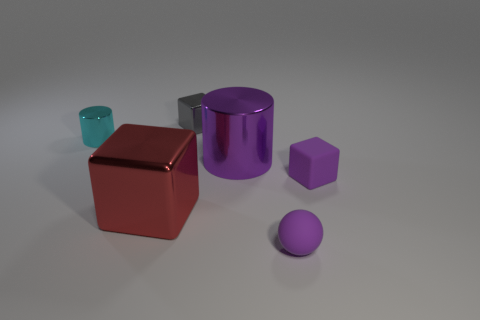Subtract all metal blocks. How many blocks are left? 1 Subtract 1 cubes. How many cubes are left? 2 Add 1 cyan matte cylinders. How many objects exist? 7 Subtract all cylinders. How many objects are left? 4 Subtract all cyan cylinders. How many cylinders are left? 1 Add 2 tiny cylinders. How many tiny cylinders exist? 3 Subtract 0 green cylinders. How many objects are left? 6 Subtract all brown spheres. Subtract all purple cubes. How many spheres are left? 1 Subtract all small purple matte spheres. Subtract all large shiny objects. How many objects are left? 3 Add 3 matte objects. How many matte objects are left? 5 